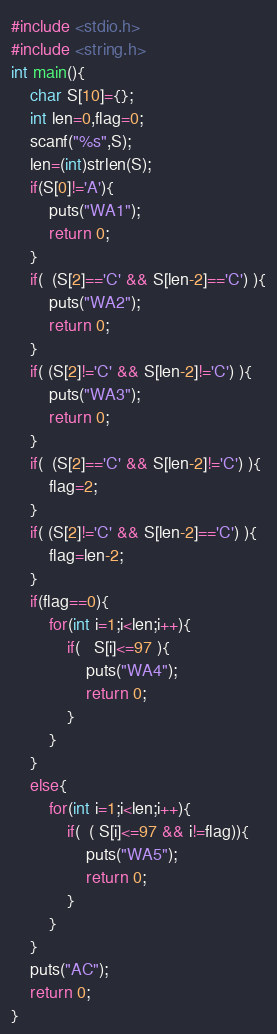<code> <loc_0><loc_0><loc_500><loc_500><_C++_>#include <stdio.h>
#include <string.h>
int main(){
    char S[10]={};
    int len=0,flag=0;
    scanf("%s",S);
    len=(int)strlen(S);
    if(S[0]!='A'){
        puts("WA1");
        return 0;
    }
    if(  (S[2]=='C' && S[len-2]=='C') ){
        puts("WA2");
        return 0;
    }
    if( (S[2]!='C' && S[len-2]!='C') ){
        puts("WA3");
        return 0;
    }
    if(  (S[2]=='C' && S[len-2]!='C') ){
        flag=2;
    }
    if( (S[2]!='C' && S[len-2]=='C') ){
        flag=len-2;
    }
    if(flag==0){
        for(int i=1;i<len;i++){
            if(   S[i]<=97 ){
                puts("WA4");
                return 0;
            }
        }
    }
    else{
        for(int i=1;i<len;i++){
            if(  ( S[i]<=97 && i!=flag)){
                puts("WA5");
                return 0;
            }
        }
    }
    puts("AC");
    return 0;
}

</code> 